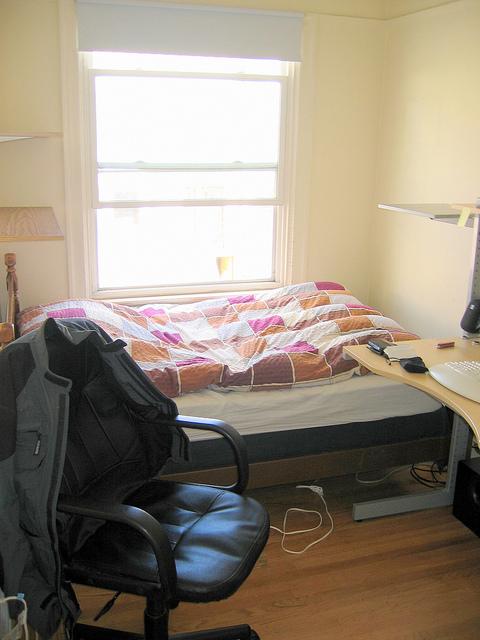Is this bed made up?
Keep it brief. Yes. Is anyone sleeping in the bed?
Be succinct. No. What is hanging on the back of the chair?
Quick response, please. Jacket. What color is the lamp?
Answer briefly. White. 